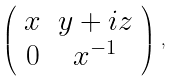Convert formula to latex. <formula><loc_0><loc_0><loc_500><loc_500>\left ( \begin{array} { c c } x & y + i z \\ 0 & x ^ { - 1 } \end{array} \right ) \, ,</formula> 